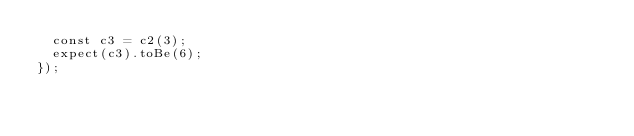<code> <loc_0><loc_0><loc_500><loc_500><_TypeScript_>  const c3 = c2(3);
  expect(c3).toBe(6);
});
</code> 